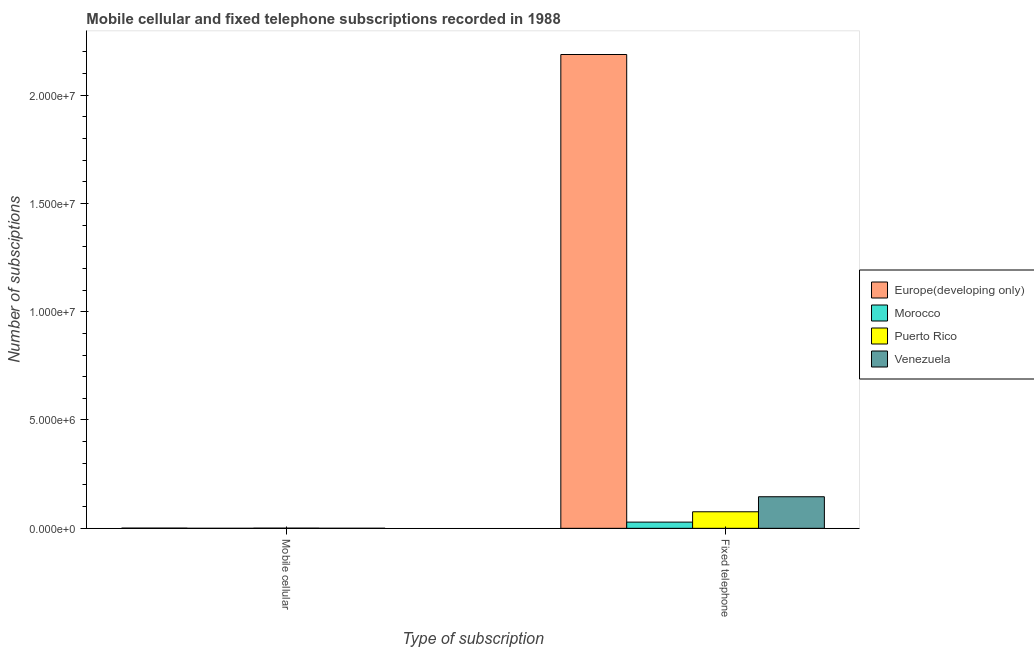How many groups of bars are there?
Your answer should be very brief. 2. Are the number of bars on each tick of the X-axis equal?
Your answer should be very brief. Yes. What is the label of the 1st group of bars from the left?
Make the answer very short. Mobile cellular. What is the number of mobile cellular subscriptions in Morocco?
Your answer should be very brief. 105. Across all countries, what is the maximum number of fixed telephone subscriptions?
Give a very brief answer. 2.19e+07. Across all countries, what is the minimum number of mobile cellular subscriptions?
Provide a succinct answer. 105. In which country was the number of fixed telephone subscriptions maximum?
Ensure brevity in your answer.  Europe(developing only). In which country was the number of fixed telephone subscriptions minimum?
Your response must be concise. Morocco. What is the total number of mobile cellular subscriptions in the graph?
Offer a terse response. 2.05e+04. What is the difference between the number of fixed telephone subscriptions in Venezuela and that in Morocco?
Your answer should be very brief. 1.17e+06. What is the difference between the number of mobile cellular subscriptions in Europe(developing only) and the number of fixed telephone subscriptions in Morocco?
Keep it short and to the point. -2.77e+05. What is the average number of mobile cellular subscriptions per country?
Make the answer very short. 5112.75. What is the difference between the number of fixed telephone subscriptions and number of mobile cellular subscriptions in Venezuela?
Keep it short and to the point. 1.46e+06. In how many countries, is the number of fixed telephone subscriptions greater than 3000000 ?
Make the answer very short. 1. What is the ratio of the number of fixed telephone subscriptions in Europe(developing only) to that in Venezuela?
Keep it short and to the point. 15. Is the number of fixed telephone subscriptions in Venezuela less than that in Europe(developing only)?
Provide a short and direct response. Yes. In how many countries, is the number of mobile cellular subscriptions greater than the average number of mobile cellular subscriptions taken over all countries?
Keep it short and to the point. 2. What does the 3rd bar from the left in Fixed telephone represents?
Your answer should be compact. Puerto Rico. What does the 2nd bar from the right in Mobile cellular represents?
Make the answer very short. Puerto Rico. How many bars are there?
Your answer should be compact. 8. Are all the bars in the graph horizontal?
Provide a short and direct response. No. Are the values on the major ticks of Y-axis written in scientific E-notation?
Ensure brevity in your answer.  Yes. Does the graph contain any zero values?
Provide a succinct answer. No. Does the graph contain grids?
Give a very brief answer. No. How are the legend labels stacked?
Your answer should be very brief. Vertical. What is the title of the graph?
Offer a terse response. Mobile cellular and fixed telephone subscriptions recorded in 1988. What is the label or title of the X-axis?
Provide a short and direct response. Type of subscription. What is the label or title of the Y-axis?
Keep it short and to the point. Number of subsciptions. What is the Number of subsciptions in Europe(developing only) in Mobile cellular?
Your answer should be compact. 9846. What is the Number of subsciptions of Morocco in Mobile cellular?
Make the answer very short. 105. What is the Number of subsciptions in Puerto Rico in Mobile cellular?
Ensure brevity in your answer.  8700. What is the Number of subsciptions in Venezuela in Mobile cellular?
Your answer should be very brief. 1800. What is the Number of subsciptions of Europe(developing only) in Fixed telephone?
Provide a short and direct response. 2.19e+07. What is the Number of subsciptions in Morocco in Fixed telephone?
Your answer should be compact. 2.86e+05. What is the Number of subsciptions of Puerto Rico in Fixed telephone?
Offer a very short reply. 7.64e+05. What is the Number of subsciptions in Venezuela in Fixed telephone?
Provide a succinct answer. 1.46e+06. Across all Type of subscription, what is the maximum Number of subsciptions in Europe(developing only)?
Ensure brevity in your answer.  2.19e+07. Across all Type of subscription, what is the maximum Number of subsciptions of Morocco?
Provide a short and direct response. 2.86e+05. Across all Type of subscription, what is the maximum Number of subsciptions in Puerto Rico?
Give a very brief answer. 7.64e+05. Across all Type of subscription, what is the maximum Number of subsciptions of Venezuela?
Your answer should be compact. 1.46e+06. Across all Type of subscription, what is the minimum Number of subsciptions of Europe(developing only)?
Your answer should be very brief. 9846. Across all Type of subscription, what is the minimum Number of subsciptions of Morocco?
Your response must be concise. 105. Across all Type of subscription, what is the minimum Number of subsciptions of Puerto Rico?
Provide a short and direct response. 8700. Across all Type of subscription, what is the minimum Number of subsciptions in Venezuela?
Offer a very short reply. 1800. What is the total Number of subsciptions of Europe(developing only) in the graph?
Provide a short and direct response. 2.19e+07. What is the total Number of subsciptions of Morocco in the graph?
Make the answer very short. 2.87e+05. What is the total Number of subsciptions of Puerto Rico in the graph?
Your answer should be compact. 7.72e+05. What is the total Number of subsciptions of Venezuela in the graph?
Your answer should be compact. 1.46e+06. What is the difference between the Number of subsciptions in Europe(developing only) in Mobile cellular and that in Fixed telephone?
Provide a short and direct response. -2.19e+07. What is the difference between the Number of subsciptions in Morocco in Mobile cellular and that in Fixed telephone?
Your answer should be compact. -2.86e+05. What is the difference between the Number of subsciptions of Puerto Rico in Mobile cellular and that in Fixed telephone?
Keep it short and to the point. -7.55e+05. What is the difference between the Number of subsciptions of Venezuela in Mobile cellular and that in Fixed telephone?
Ensure brevity in your answer.  -1.46e+06. What is the difference between the Number of subsciptions in Europe(developing only) in Mobile cellular and the Number of subsciptions in Morocco in Fixed telephone?
Give a very brief answer. -2.77e+05. What is the difference between the Number of subsciptions of Europe(developing only) in Mobile cellular and the Number of subsciptions of Puerto Rico in Fixed telephone?
Provide a short and direct response. -7.54e+05. What is the difference between the Number of subsciptions in Europe(developing only) in Mobile cellular and the Number of subsciptions in Venezuela in Fixed telephone?
Ensure brevity in your answer.  -1.45e+06. What is the difference between the Number of subsciptions in Morocco in Mobile cellular and the Number of subsciptions in Puerto Rico in Fixed telephone?
Provide a short and direct response. -7.63e+05. What is the difference between the Number of subsciptions of Morocco in Mobile cellular and the Number of subsciptions of Venezuela in Fixed telephone?
Ensure brevity in your answer.  -1.46e+06. What is the difference between the Number of subsciptions in Puerto Rico in Mobile cellular and the Number of subsciptions in Venezuela in Fixed telephone?
Your answer should be compact. -1.45e+06. What is the average Number of subsciptions in Europe(developing only) per Type of subscription?
Your answer should be compact. 1.09e+07. What is the average Number of subsciptions in Morocco per Type of subscription?
Ensure brevity in your answer.  1.43e+05. What is the average Number of subsciptions of Puerto Rico per Type of subscription?
Your answer should be compact. 3.86e+05. What is the average Number of subsciptions of Venezuela per Type of subscription?
Make the answer very short. 7.30e+05. What is the difference between the Number of subsciptions in Europe(developing only) and Number of subsciptions in Morocco in Mobile cellular?
Ensure brevity in your answer.  9741. What is the difference between the Number of subsciptions in Europe(developing only) and Number of subsciptions in Puerto Rico in Mobile cellular?
Offer a terse response. 1146. What is the difference between the Number of subsciptions in Europe(developing only) and Number of subsciptions in Venezuela in Mobile cellular?
Give a very brief answer. 8046. What is the difference between the Number of subsciptions in Morocco and Number of subsciptions in Puerto Rico in Mobile cellular?
Your answer should be compact. -8595. What is the difference between the Number of subsciptions in Morocco and Number of subsciptions in Venezuela in Mobile cellular?
Your response must be concise. -1695. What is the difference between the Number of subsciptions in Puerto Rico and Number of subsciptions in Venezuela in Mobile cellular?
Your answer should be compact. 6900. What is the difference between the Number of subsciptions in Europe(developing only) and Number of subsciptions in Morocco in Fixed telephone?
Your answer should be compact. 2.16e+07. What is the difference between the Number of subsciptions of Europe(developing only) and Number of subsciptions of Puerto Rico in Fixed telephone?
Give a very brief answer. 2.11e+07. What is the difference between the Number of subsciptions of Europe(developing only) and Number of subsciptions of Venezuela in Fixed telephone?
Keep it short and to the point. 2.04e+07. What is the difference between the Number of subsciptions of Morocco and Number of subsciptions of Puerto Rico in Fixed telephone?
Your response must be concise. -4.77e+05. What is the difference between the Number of subsciptions in Morocco and Number of subsciptions in Venezuela in Fixed telephone?
Give a very brief answer. -1.17e+06. What is the difference between the Number of subsciptions in Puerto Rico and Number of subsciptions in Venezuela in Fixed telephone?
Your answer should be very brief. -6.94e+05. What is the ratio of the Number of subsciptions in Morocco in Mobile cellular to that in Fixed telephone?
Your answer should be compact. 0. What is the ratio of the Number of subsciptions in Puerto Rico in Mobile cellular to that in Fixed telephone?
Give a very brief answer. 0.01. What is the ratio of the Number of subsciptions in Venezuela in Mobile cellular to that in Fixed telephone?
Offer a very short reply. 0. What is the difference between the highest and the second highest Number of subsciptions of Europe(developing only)?
Your response must be concise. 2.19e+07. What is the difference between the highest and the second highest Number of subsciptions of Morocco?
Offer a very short reply. 2.86e+05. What is the difference between the highest and the second highest Number of subsciptions of Puerto Rico?
Provide a short and direct response. 7.55e+05. What is the difference between the highest and the second highest Number of subsciptions of Venezuela?
Your response must be concise. 1.46e+06. What is the difference between the highest and the lowest Number of subsciptions of Europe(developing only)?
Ensure brevity in your answer.  2.19e+07. What is the difference between the highest and the lowest Number of subsciptions in Morocco?
Make the answer very short. 2.86e+05. What is the difference between the highest and the lowest Number of subsciptions of Puerto Rico?
Offer a terse response. 7.55e+05. What is the difference between the highest and the lowest Number of subsciptions of Venezuela?
Your response must be concise. 1.46e+06. 